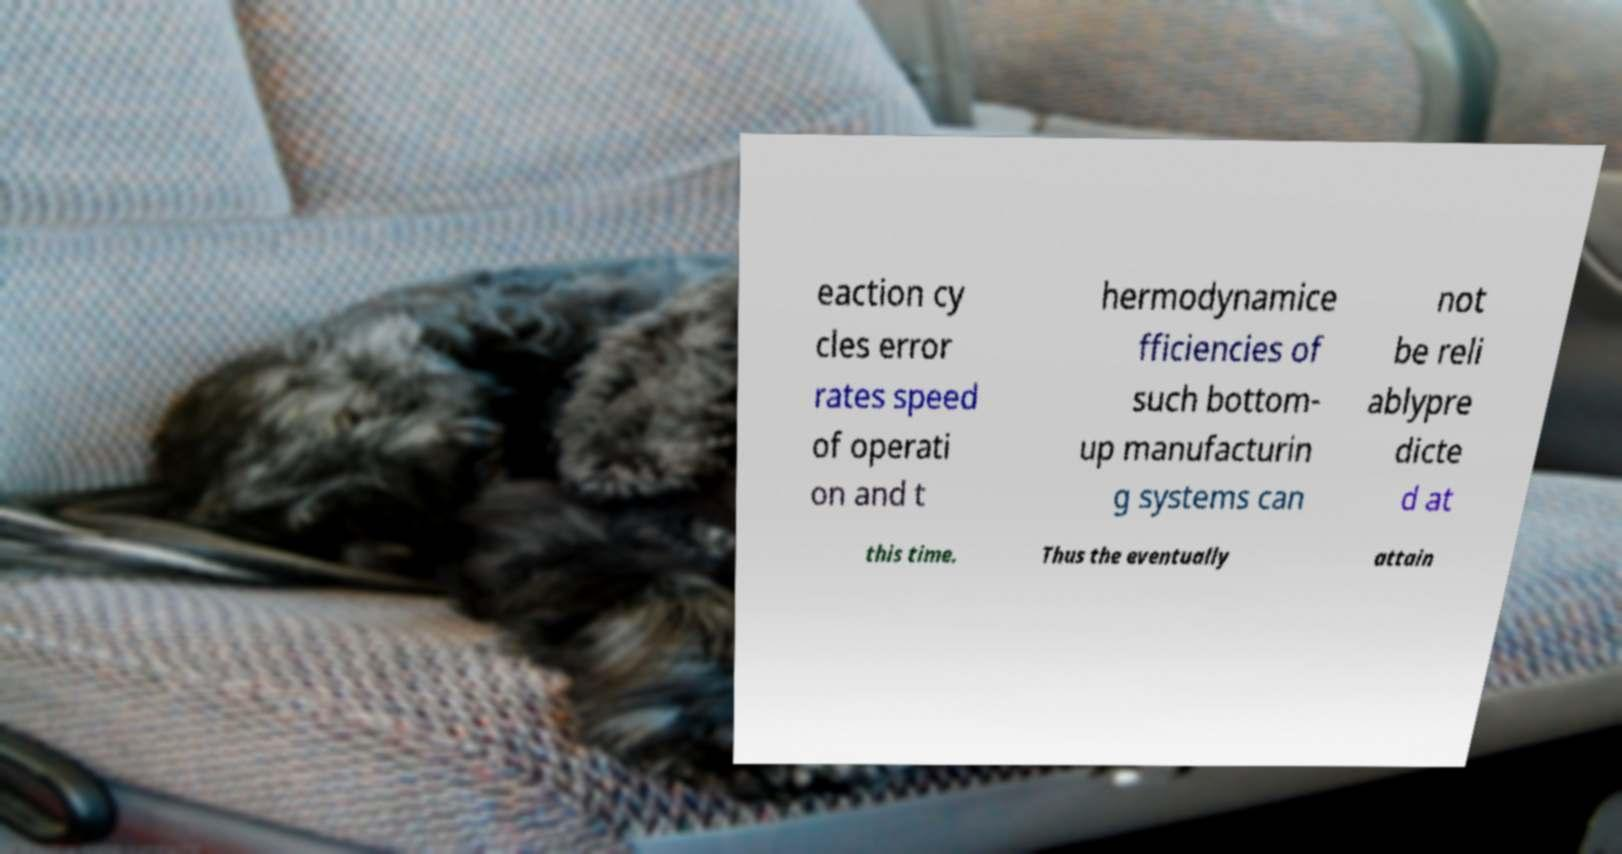Please read and relay the text visible in this image. What does it say? eaction cy cles error rates speed of operati on and t hermodynamice fficiencies of such bottom- up manufacturin g systems can not be reli ablypre dicte d at this time. Thus the eventually attain 